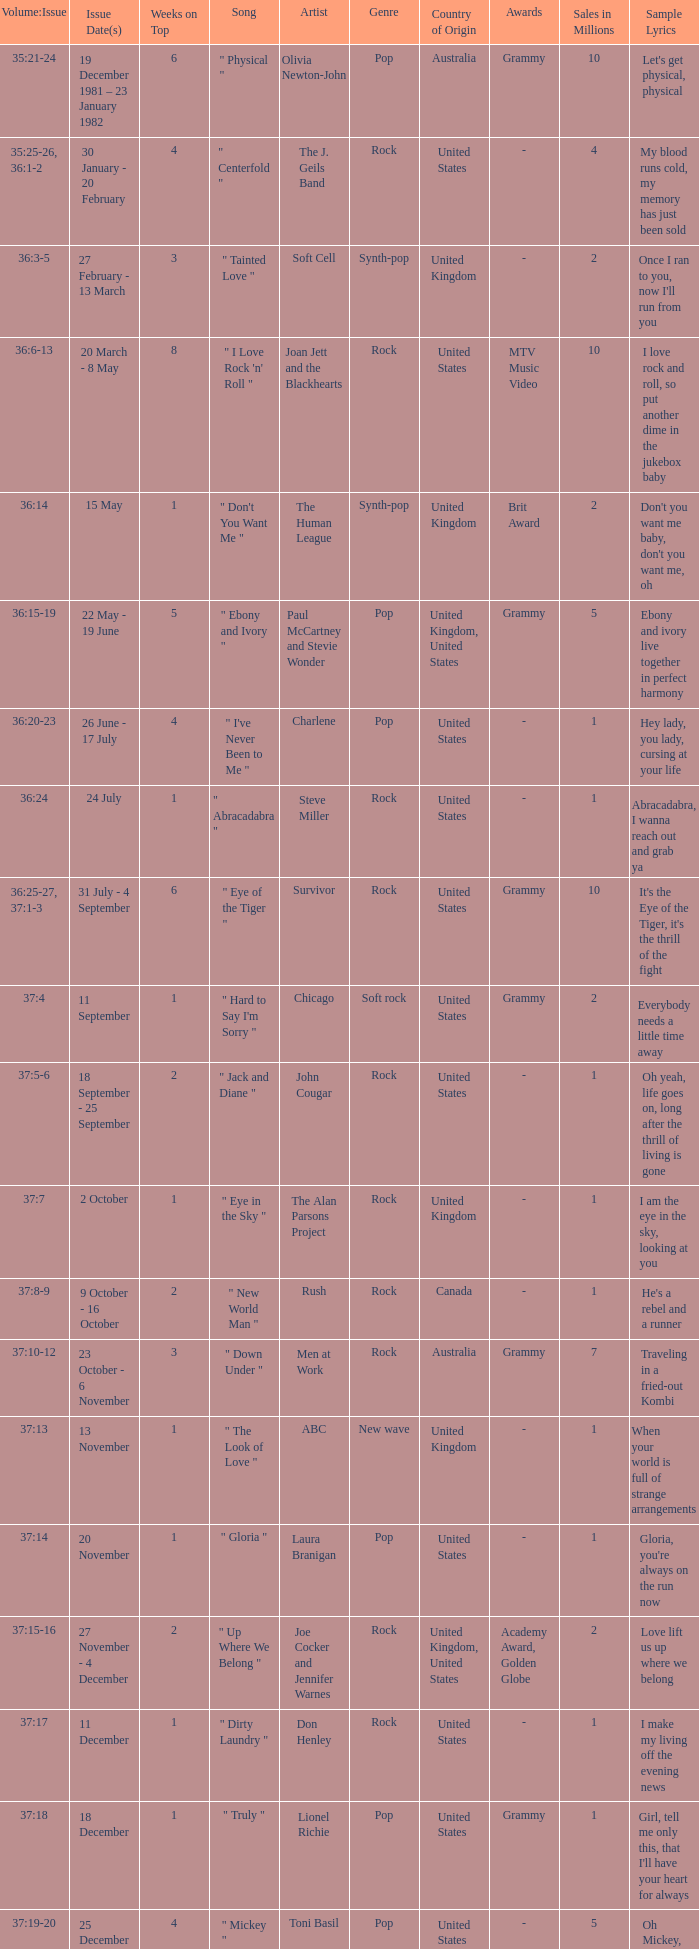Which Issue Date(s) has an Artist of men at work? 23 October - 6 November. 